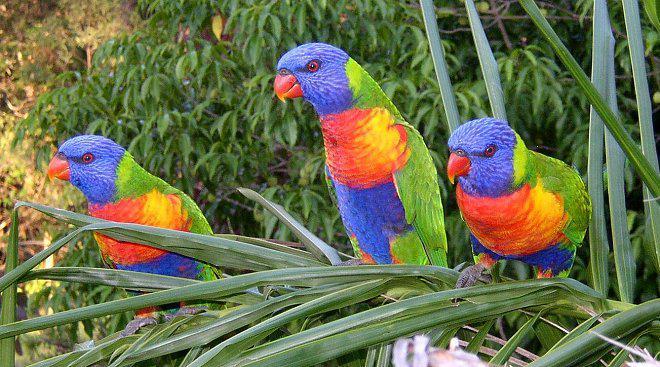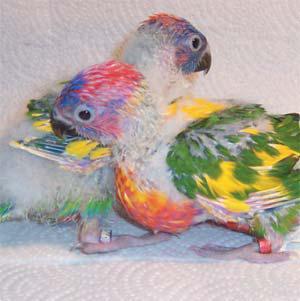The first image is the image on the left, the second image is the image on the right. For the images displayed, is the sentence "Some birds are touching each other in at least one photo." factually correct? Answer yes or no. Yes. The first image is the image on the left, the second image is the image on the right. Considering the images on both sides, is "The left image contains only one multi-colored parrot." valid? Answer yes or no. No. 